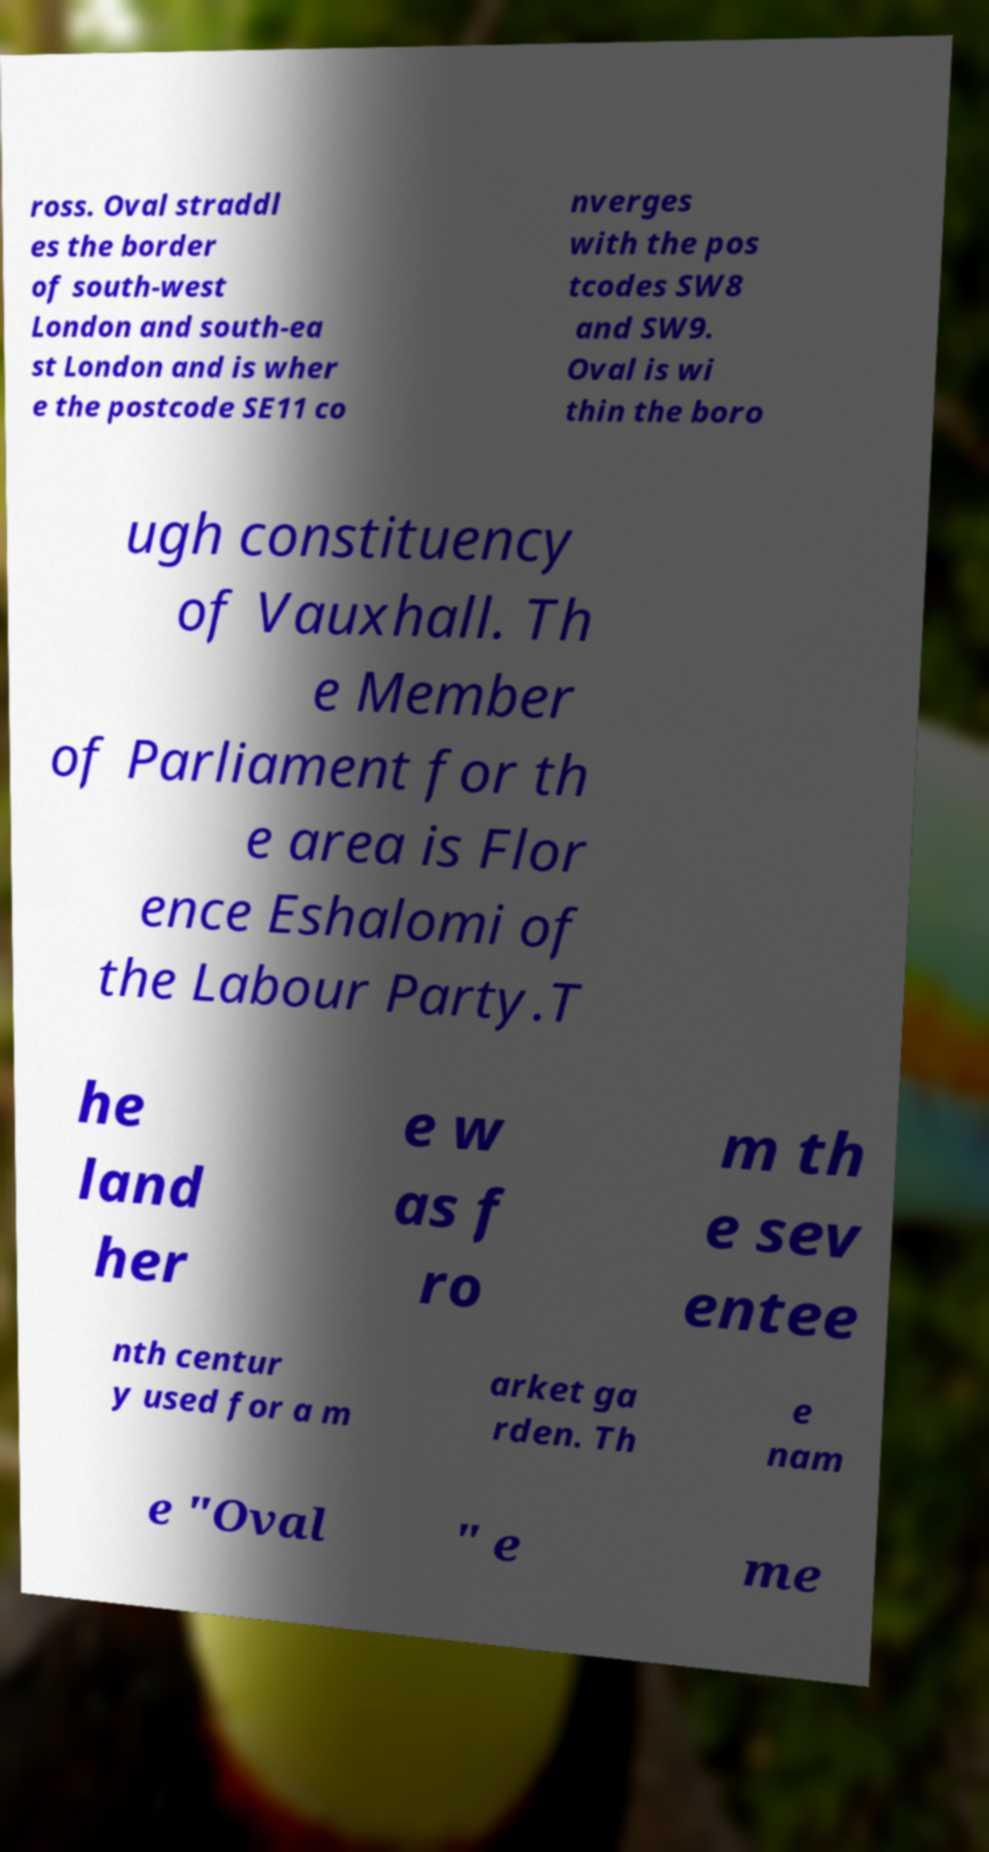There's text embedded in this image that I need extracted. Can you transcribe it verbatim? ross. Oval straddl es the border of south-west London and south-ea st London and is wher e the postcode SE11 co nverges with the pos tcodes SW8 and SW9. Oval is wi thin the boro ugh constituency of Vauxhall. Th e Member of Parliament for th e area is Flor ence Eshalomi of the Labour Party.T he land her e w as f ro m th e sev entee nth centur y used for a m arket ga rden. Th e nam e "Oval " e me 